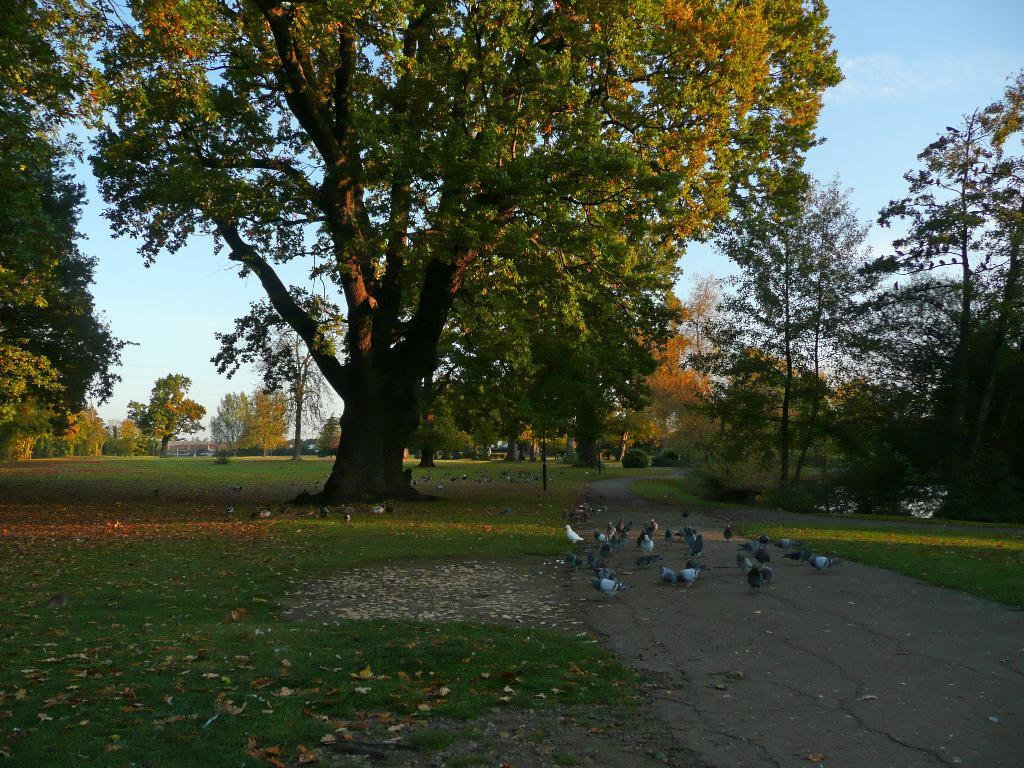What type of ground surface is visible in the image? There is green grass on the ground in the image. What other natural elements can be seen in the image? There are trees in the image. What color is the sky in the image? The sky is blue in the image. Reasoning: Let'g: Let's think step by step in order to produce the conversation. We start by identifying the main ground surface in the image, which is green grass. Then, we expand the conversation to include other natural elements, such as trees. Finally, we describe the sky's color, which is blue. Each question is designed to elicit a specific detail about the image that is known from the provided facts. Absurd Question/Answer: Who is the owner of the building in the image? There is no building present in the image, so it is not possible to determine the owner. What type of surprise can be seen in the image? There is no surprise present in the image; it features green grass, trees, and a blue sky. 